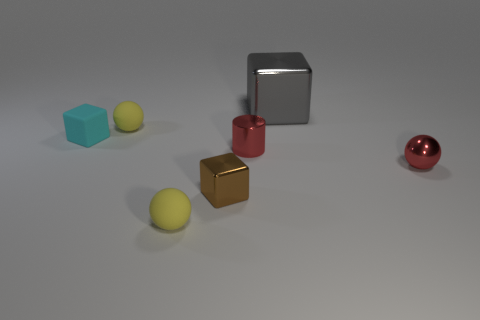What number of other objects are there of the same color as the big metal cube?
Ensure brevity in your answer.  0. Are there more tiny yellow balls behind the large gray metal cube than big cubes?
Make the answer very short. No. What is the color of the small matte object that is left of the matte ball that is behind the yellow matte thing that is in front of the brown metallic cube?
Provide a short and direct response. Cyan. Does the tiny cyan cube have the same material as the red sphere?
Keep it short and to the point. No. Are there any yellow rubber things that have the same size as the red metallic ball?
Your answer should be compact. Yes. What is the material of the other block that is the same size as the brown block?
Make the answer very short. Rubber. Are there any large cyan metal things of the same shape as the large gray metallic object?
Provide a short and direct response. No. There is a small object that is the same color as the metal sphere; what is it made of?
Your answer should be compact. Metal. There is a yellow object that is behind the rubber cube; what shape is it?
Your response must be concise. Sphere. What number of large red objects are there?
Your answer should be compact. 0. 